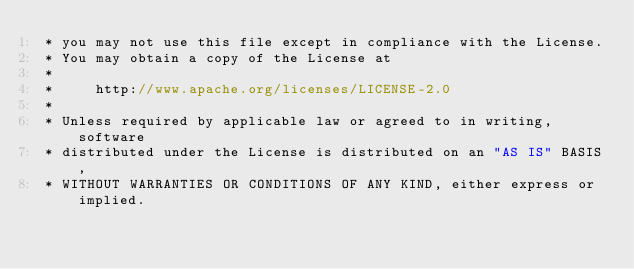Convert code to text. <code><loc_0><loc_0><loc_500><loc_500><_ObjectiveC_> * you may not use this file except in compliance with the License.
 * You may obtain a copy of the License at
 * 
 *     http://www.apache.org/licenses/LICENSE-2.0
 * 
 * Unless required by applicable law or agreed to in writing, software
 * distributed under the License is distributed on an "AS IS" BASIS,
 * WITHOUT WARRANTIES OR CONDITIONS OF ANY KIND, either express or implied.</code> 